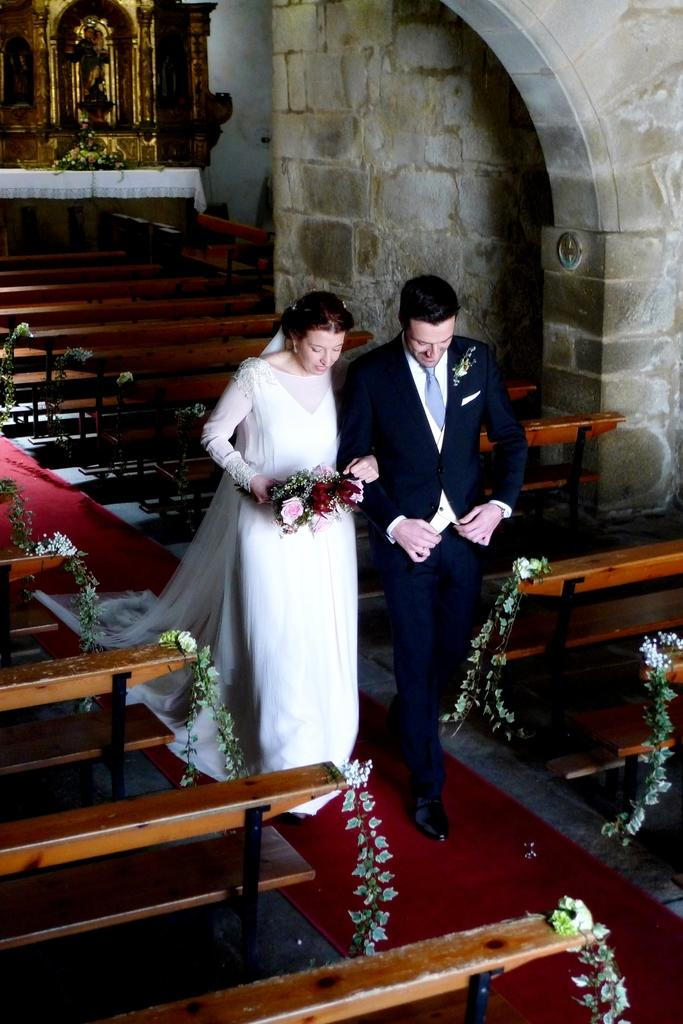What are the two people in the image doing? There is a couple walking in the image. What type of seating is present in the image? There are benches in the image. What architectural feature can be seen in the image? There is an arch in the image. What type of structure is visible in the image? There is a wall in the image. What type of vegetation is present in the image? There are flowers in the image. What type of drain is visible in the image? There is no drain present in the image. What type of beam is supporting the arch in the image? There is no beam visible in the image, as the focus is on the arch itself and not its structural support. 